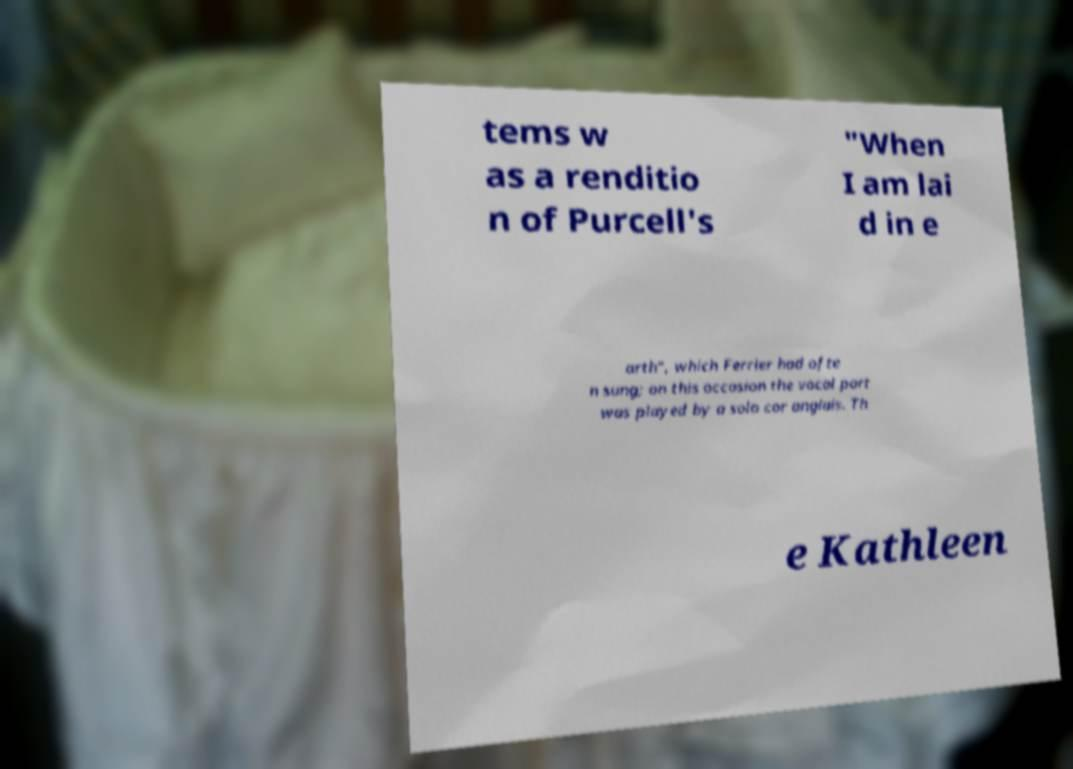Could you extract and type out the text from this image? tems w as a renditio n of Purcell's "When I am lai d in e arth", which Ferrier had ofte n sung; on this occasion the vocal part was played by a solo cor anglais. Th e Kathleen 